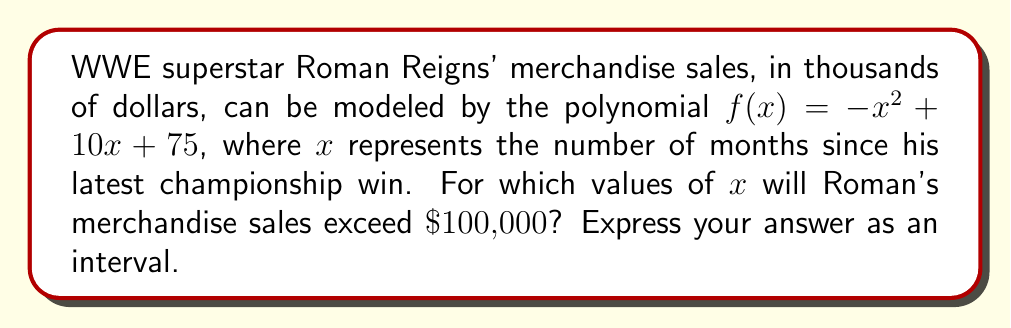Teach me how to tackle this problem. To solve this polynomial inequality, we need to follow these steps:

1) Set up the inequality:
   $f(x) > 100$
   $-x^2 + 10x + 75 > 100$

2) Rearrange the inequality:
   $-x^2 + 10x - 25 > 0$

3) Factor the left side:
   $-(x^2 - 10x + 25) > 0$
   $-(x - 5)^2 > 0$

4) Solve the inequality:
   $-(x - 5)^2 > 0$
   $(x - 5)^2 < 0$

   The square of a real number is always non-negative, so this inequality has no real solutions.

5) However, the original inequality is greater than, not less than. So we need to reverse our inequality:
   $-(x - 5)^2 > 0$
   $(x - 5)^2 < 0$

   This is true for all real numbers except when $(x - 5)^2 = 0$, which occurs when $x = 5$.

6) Therefore, the solution is all real numbers except 5, which we can express as an interval:
   $(-\infty, 5) \cup (5, \infty)$

This means Roman's merchandise sales will exceed $100,000 for any number of months except exactly 5 months after his latest championship win.
Answer: $(-\infty, 5) \cup (5, \infty)$ 